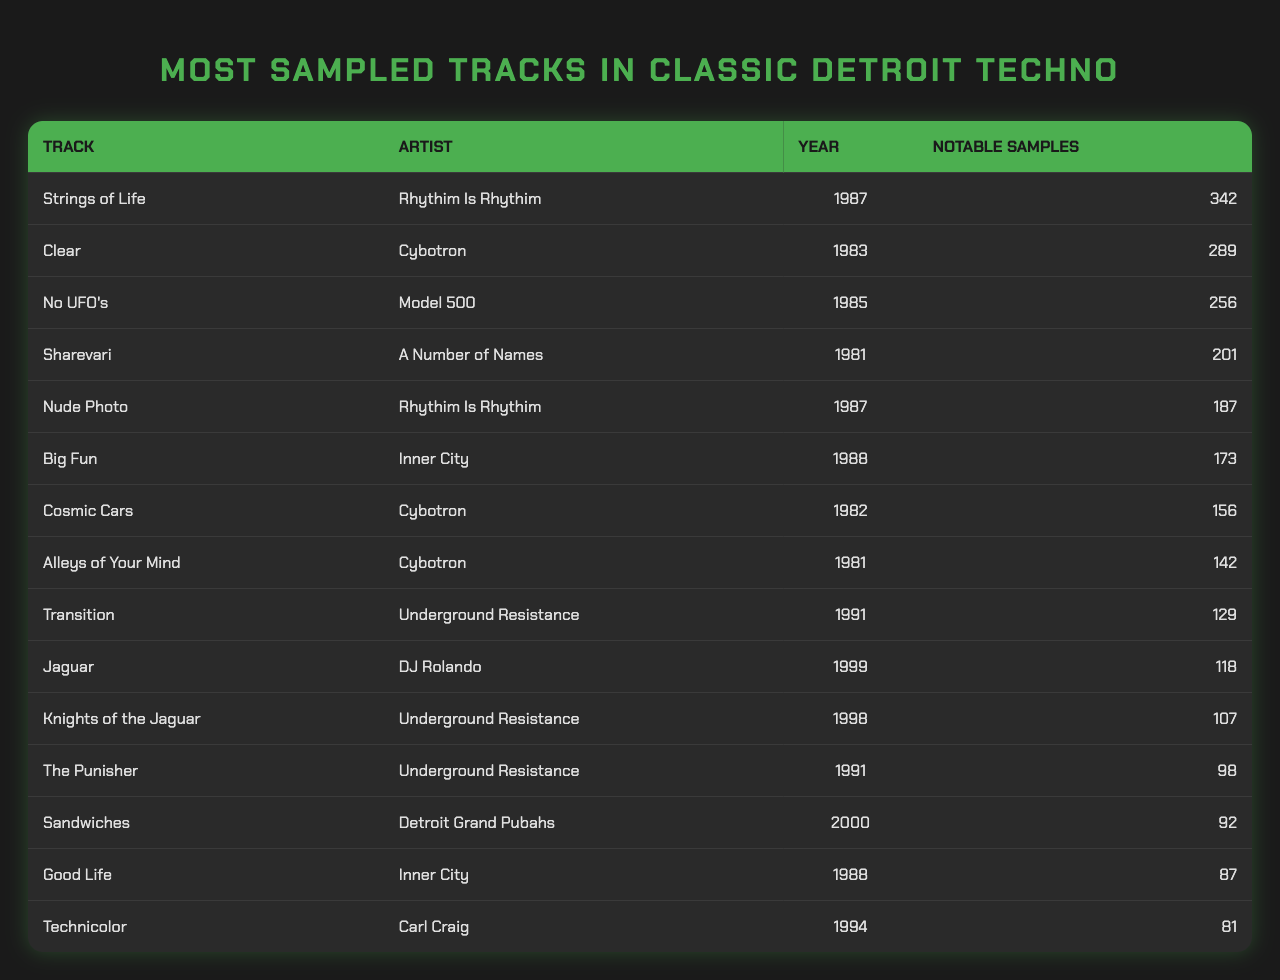What is the title of the most sampled track in classic Detroit techno? The most sampled track is listed first in the table, which shows "Strings of Life" at the top.
Answer: Strings of Life Which artist created the track "Clear"? By looking at the row corresponding to "Clear," we see that Cybotron is the artist associated with this track.
Answer: Cybotron How many notable samples does "No UFO's" have? The row for "No UFO's" indicates that it has 256 notable samples, which is explicitly mentioned in the table.
Answer: 256 Which track has the least number of notable samples, and how many does it have? The track at the bottom of the list is "Technicolor" with 81 notable samples, as confirmed by its placement in the data.
Answer: Technicolor, 81 What year was "Jaguar" released? The table indicates that "Jaguar" was released in 1999, which can be confirmed from the year column.
Answer: 1999 What are the total number of notable samples for tracks by Underground Resistance? There are three tracks by Underground Resistance: "Transition" (129), "Knights of the Jaguar" (107), and "The Punisher" (98). The total is 129 + 107 + 98 = 334 notable samples.
Answer: 334 Is "Nude Photo" sampled more than "Big Fun"? "Nude Photo" has 187 samples, while "Big Fun" has 173, confirming that "Nude Photo" is indeed sampled more.
Answer: Yes Which artist has the highest number of sampled tracks listed? By examining the artists in the table, Cybotron is listed for three tracks ("Clear," "Cosmic Cars," and "Alleys of Your Mind"), which is the highest among all artists in the data.
Answer: Cybotron What is the difference in notable samples between "Strings of Life" and "Sharevari"? "Strings of Life" has 342 samples and "Sharevari" has 201 samples. The difference is 342 - 201 = 141 notable samples.
Answer: 141 Which track released in 1988 has the lowest number of notable samples? Two tracks from 1988 are "Big Fun" (173) and "Good Life" (87). Comparing these, "Good Life" has the lowest at 87 notable samples.
Answer: Good Life, 87 